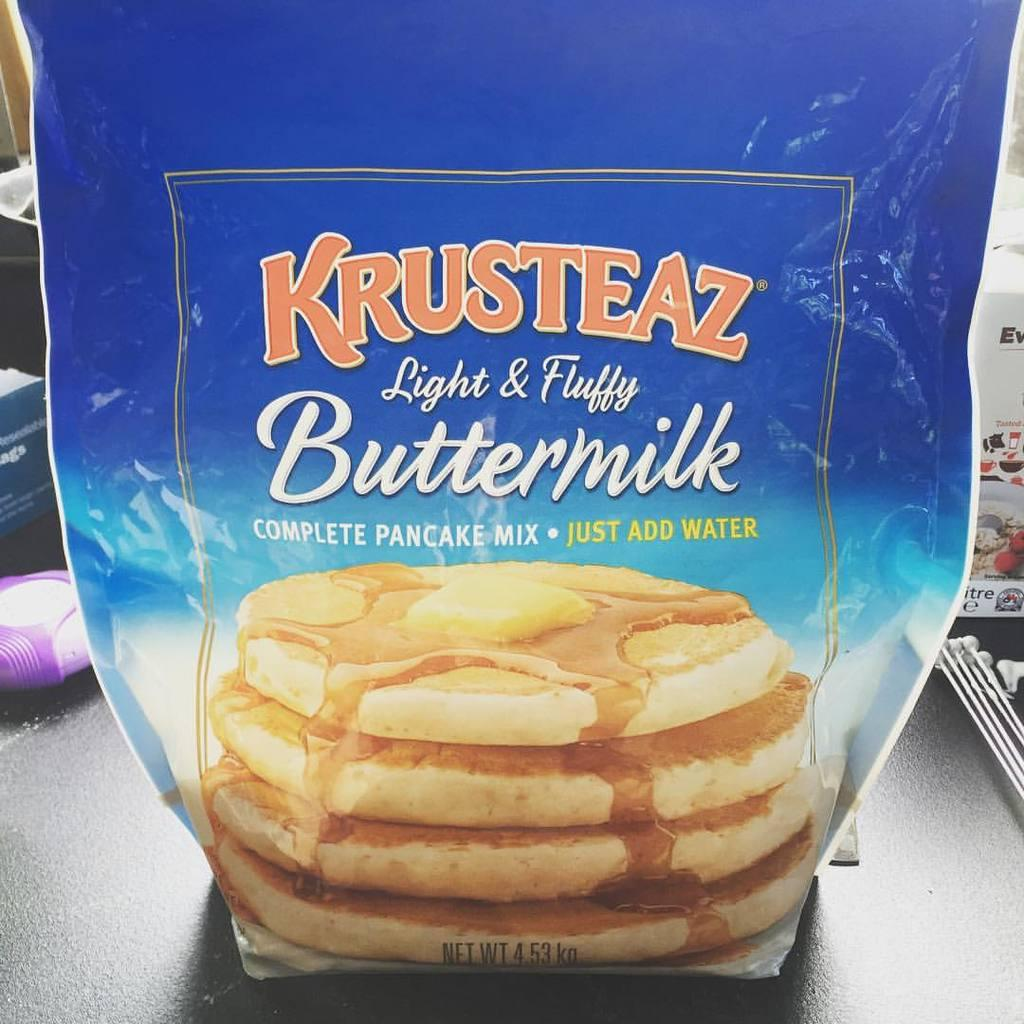What is located at the bottom of the image? There is a table at the bottom of the image. What is on the table? There is a packet on the table. Can you describe what else is placed on the table? There are some things placed on the table, but the specific items are not mentioned in the facts. What type of twig can be seen in the image? There is no twig present in the image. 